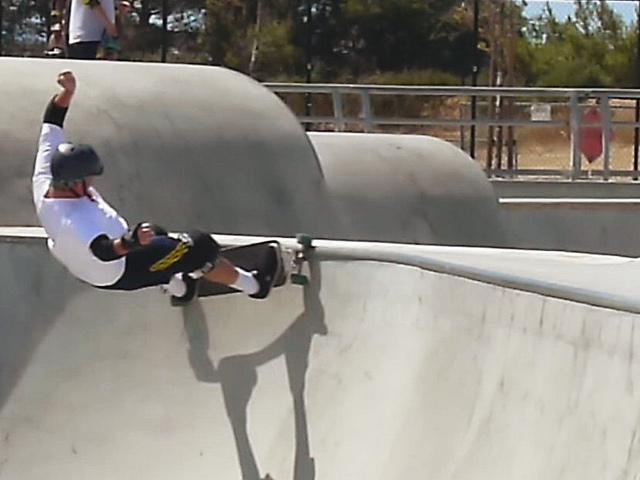Is  the skater safe?
Answer briefly. Yes. Is he wearing a helmet?
Give a very brief answer. Yes. What is casting a shadow on the ground?
Answer briefly. Skateboarder. 